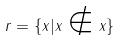Convert formula to latex. <formula><loc_0><loc_0><loc_500><loc_500>r = \{ x | x \notin x \}</formula> 